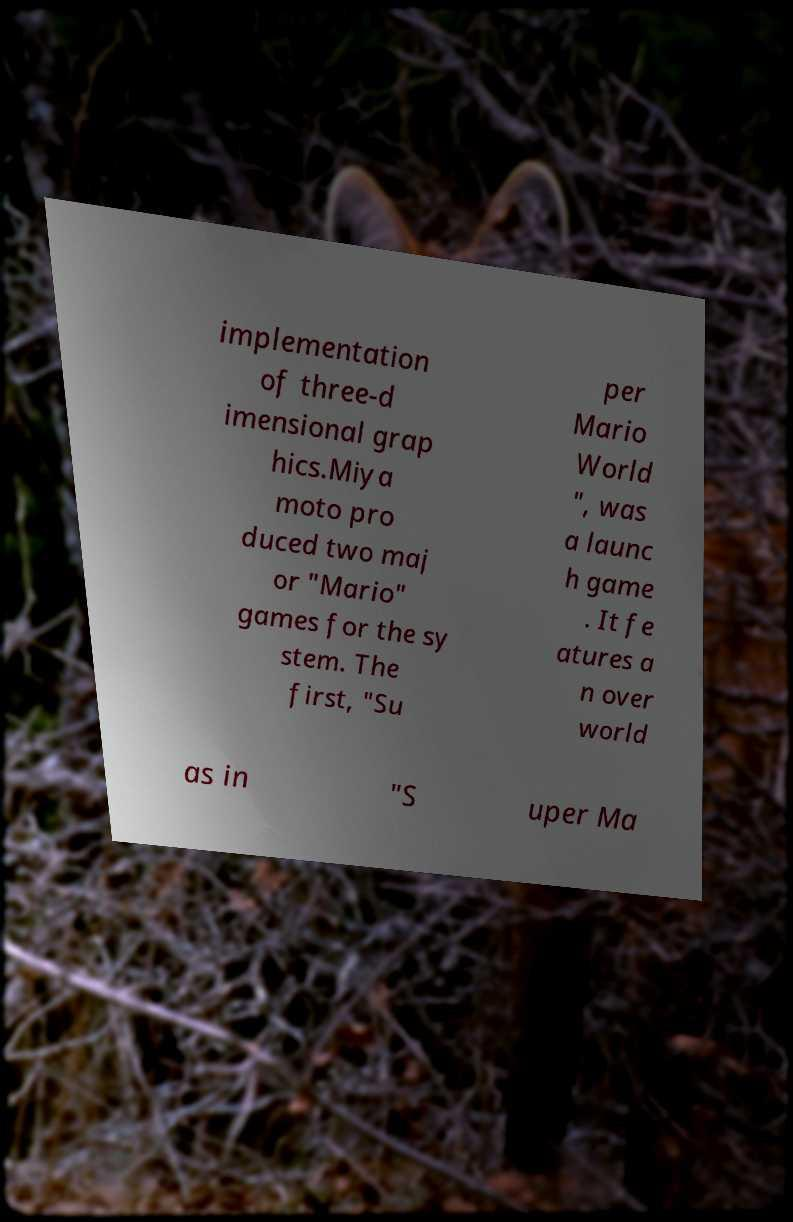Please identify and transcribe the text found in this image. implementation of three-d imensional grap hics.Miya moto pro duced two maj or "Mario" games for the sy stem. The first, "Su per Mario World ", was a launc h game . It fe atures a n over world as in "S uper Ma 